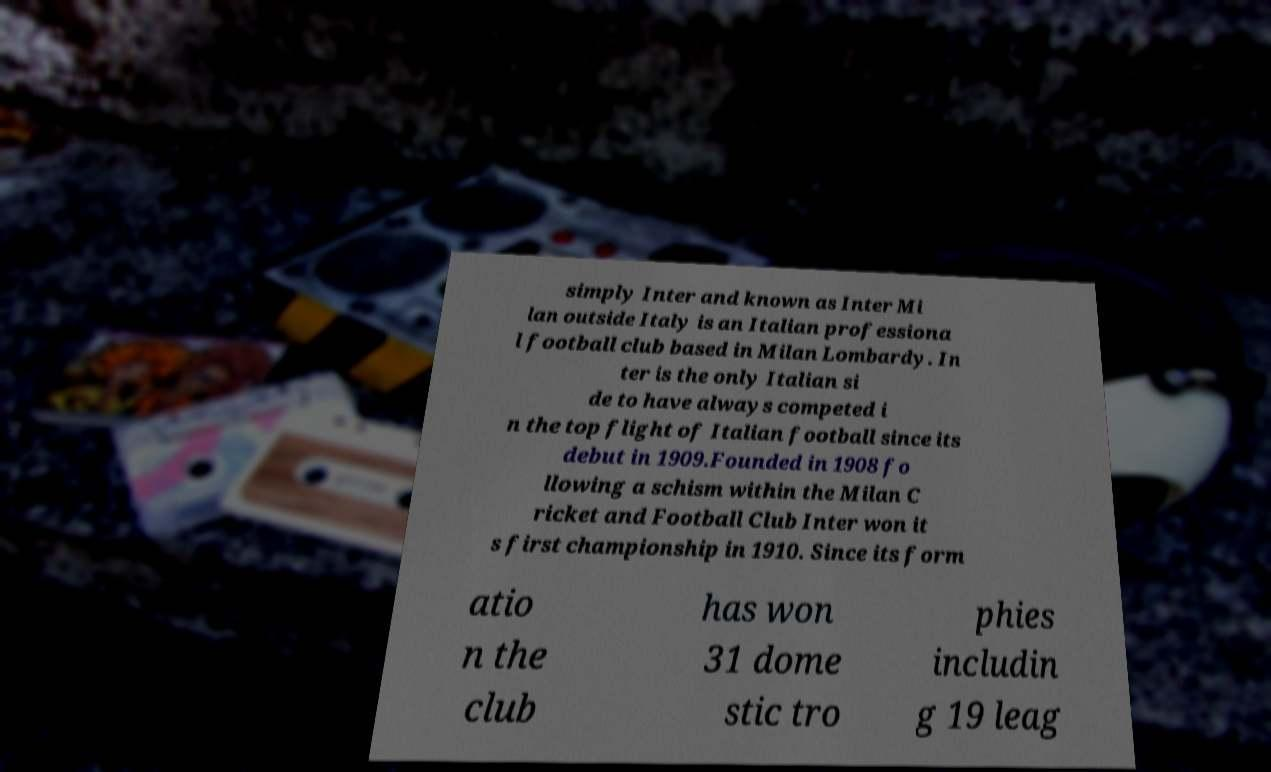Could you extract and type out the text from this image? simply Inter and known as Inter Mi lan outside Italy is an Italian professiona l football club based in Milan Lombardy. In ter is the only Italian si de to have always competed i n the top flight of Italian football since its debut in 1909.Founded in 1908 fo llowing a schism within the Milan C ricket and Football Club Inter won it s first championship in 1910. Since its form atio n the club has won 31 dome stic tro phies includin g 19 leag 